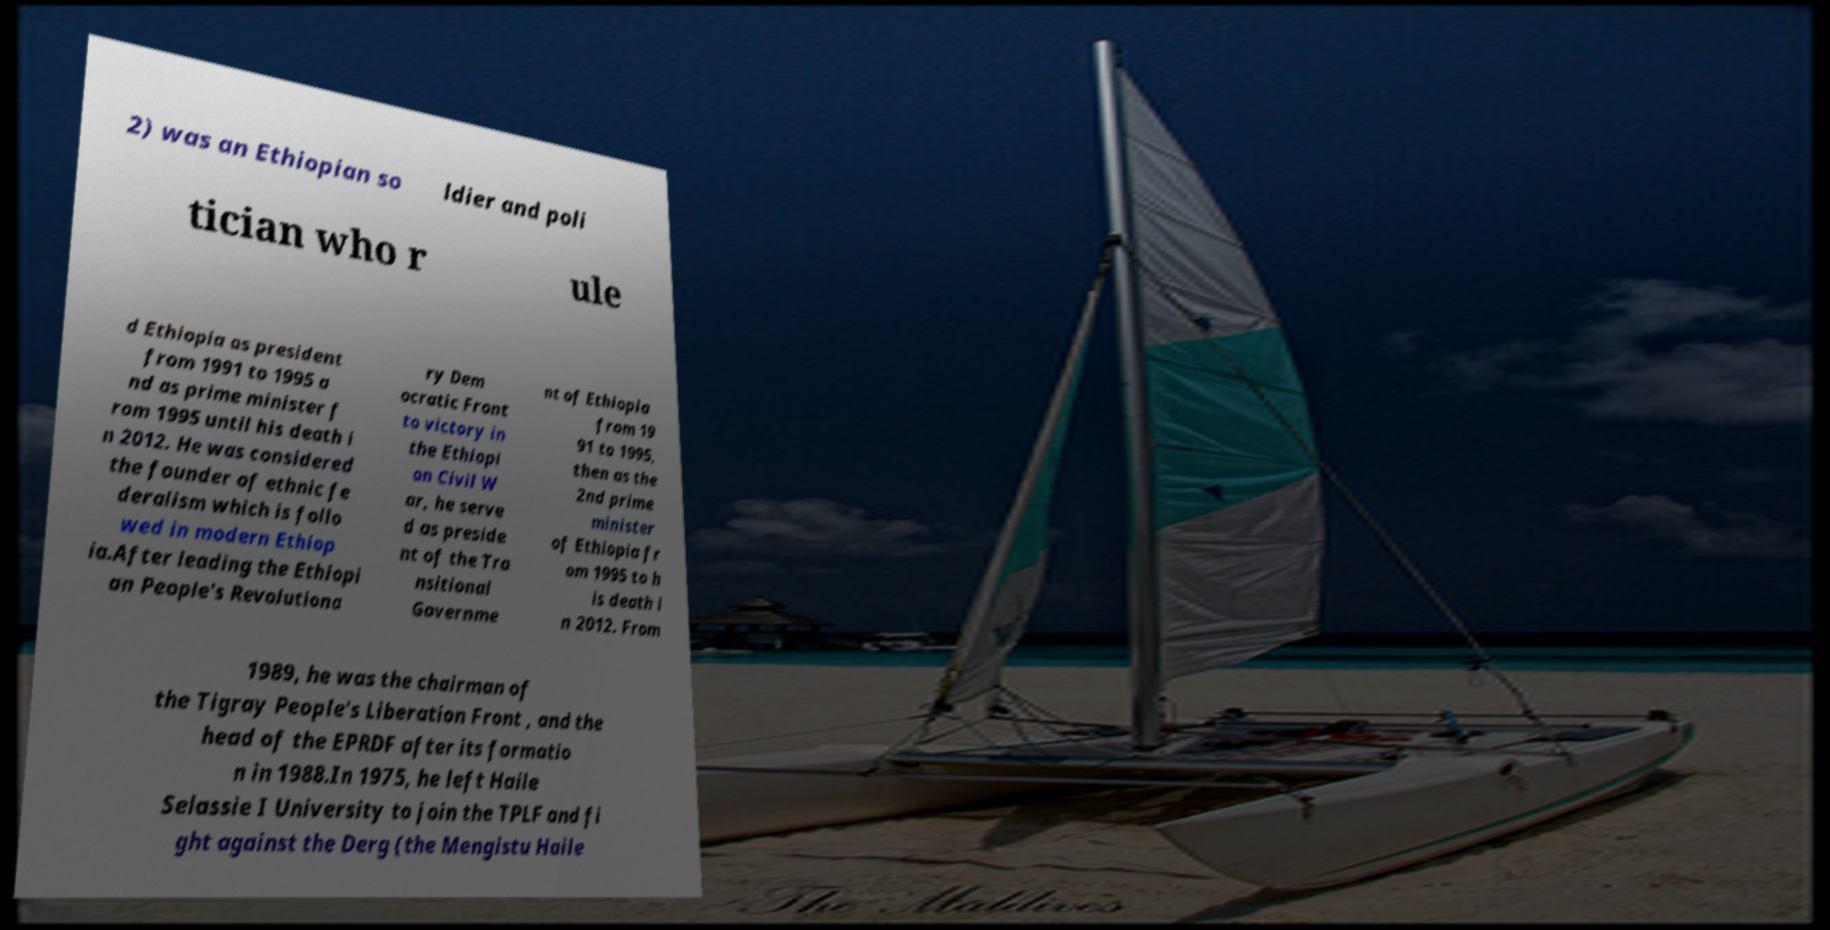Could you extract and type out the text from this image? 2) was an Ethiopian so ldier and poli tician who r ule d Ethiopia as president from 1991 to 1995 a nd as prime minister f rom 1995 until his death i n 2012. He was considered the founder of ethnic fe deralism which is follo wed in modern Ethiop ia.After leading the Ethiopi an People's Revolutiona ry Dem ocratic Front to victory in the Ethiopi an Civil W ar, he serve d as preside nt of the Tra nsitional Governme nt of Ethiopia from 19 91 to 1995, then as the 2nd prime minister of Ethiopia fr om 1995 to h is death i n 2012. From 1989, he was the chairman of the Tigray People's Liberation Front , and the head of the EPRDF after its formatio n in 1988.In 1975, he left Haile Selassie I University to join the TPLF and fi ght against the Derg (the Mengistu Haile 